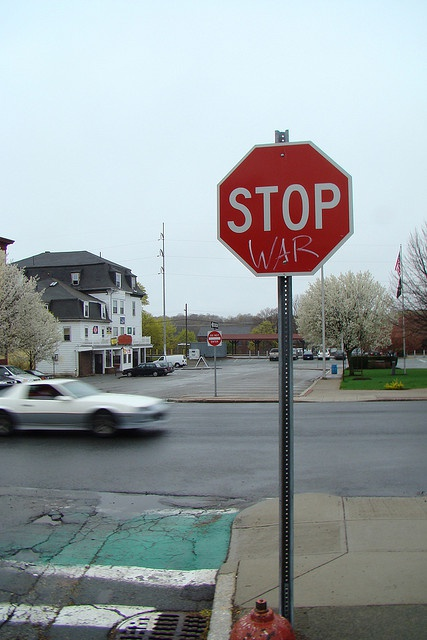Describe the objects in this image and their specific colors. I can see stop sign in lightblue, maroon, darkgray, and brown tones, car in lightblue, black, lightgray, darkgray, and gray tones, fire hydrant in lightblue, maroon, brown, and black tones, car in lightblue, black, gray, teal, and maroon tones, and car in lightblue, black, gray, and darkgray tones in this image. 